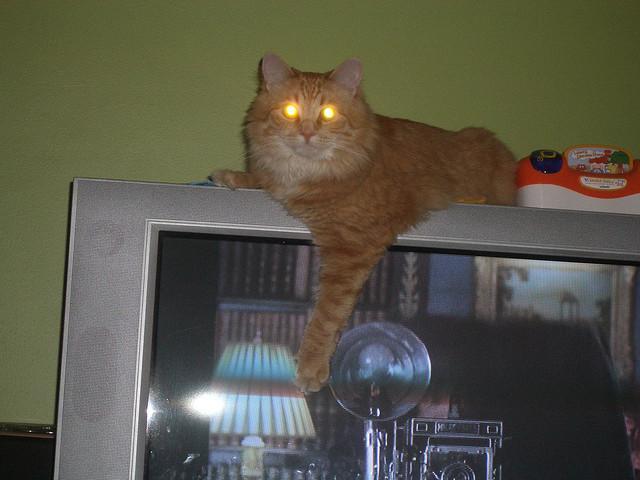How many people are wearing protective face masks?
Give a very brief answer. 0. 